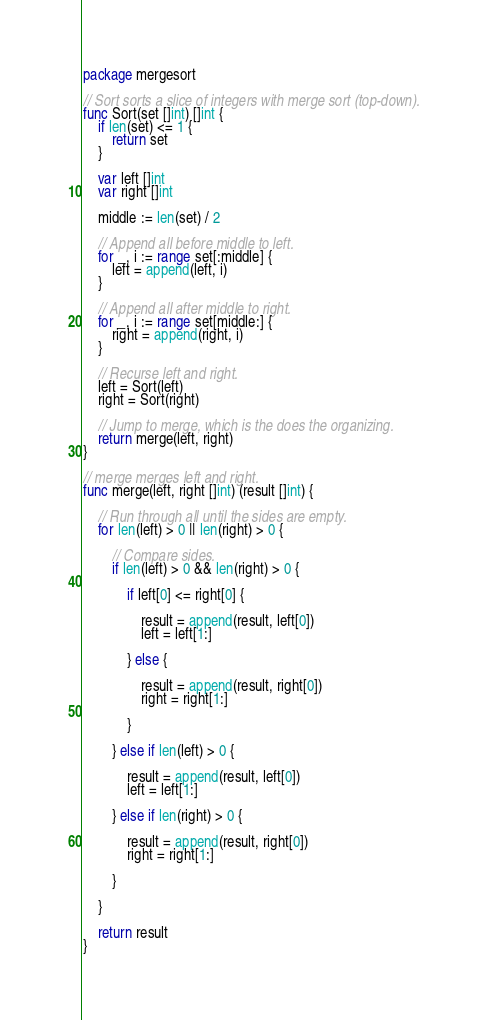Convert code to text. <code><loc_0><loc_0><loc_500><loc_500><_Go_>package mergesort

// Sort sorts a slice of integers with merge sort (top-down).
func Sort(set []int) []int {
	if len(set) <= 1 {
		return set
	}

	var left []int
	var right []int

	middle := len(set) / 2

	// Append all before middle to left.
	for _, i := range set[:middle] {
		left = append(left, i)
	}

	// Append all after middle to right.
	for _, i := range set[middle:] {
		right = append(right, i)
	}

	// Recurse left and right.
	left = Sort(left)
	right = Sort(right)

	// Jump to merge, which is the does the organizing.
	return merge(left, right)
}

// merge merges left and right.
func merge(left, right []int) (result []int) {

	// Run through all until the sides are empty.
	for len(left) > 0 || len(right) > 0 {

		// Compare sides.
		if len(left) > 0 && len(right) > 0 {

			if left[0] <= right[0] {

				result = append(result, left[0])
				left = left[1:]

			} else {

				result = append(result, right[0])
				right = right[1:]

			}

		} else if len(left) > 0 {

			result = append(result, left[0])
			left = left[1:]

		} else if len(right) > 0 {

			result = append(result, right[0])
			right = right[1:]

		}

	}

	return result
}
</code> 